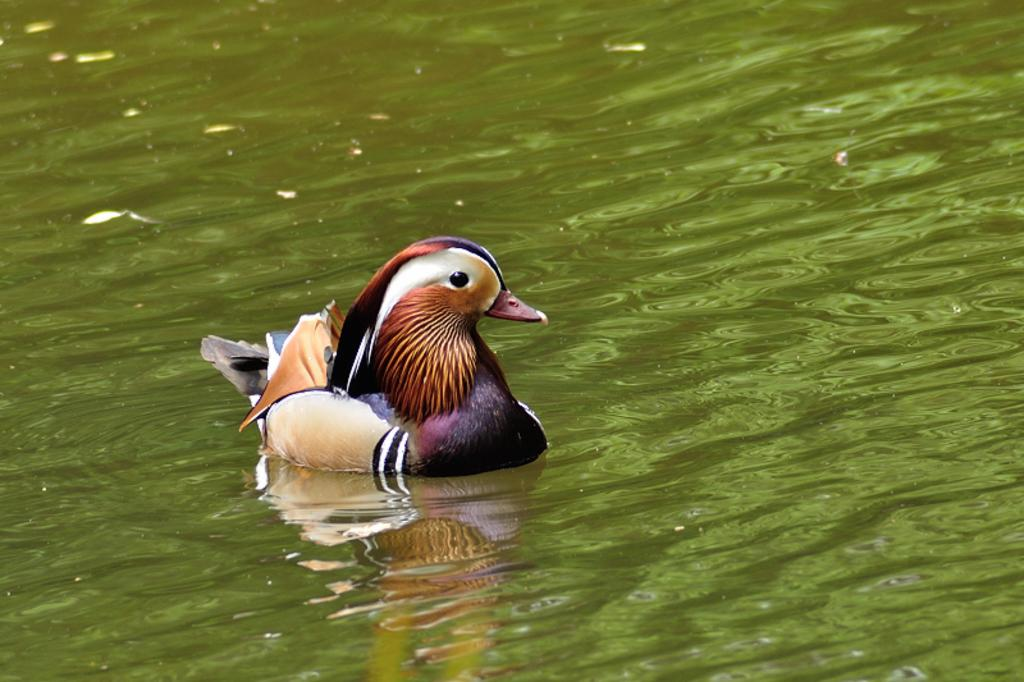What type of animal is in the image? There is a bird in the image. Where is the bird located in the image? The bird is in the water. What color is the grape that the bird is holding in the image? There is no grape present in the image, and the bird is not holding anything. 